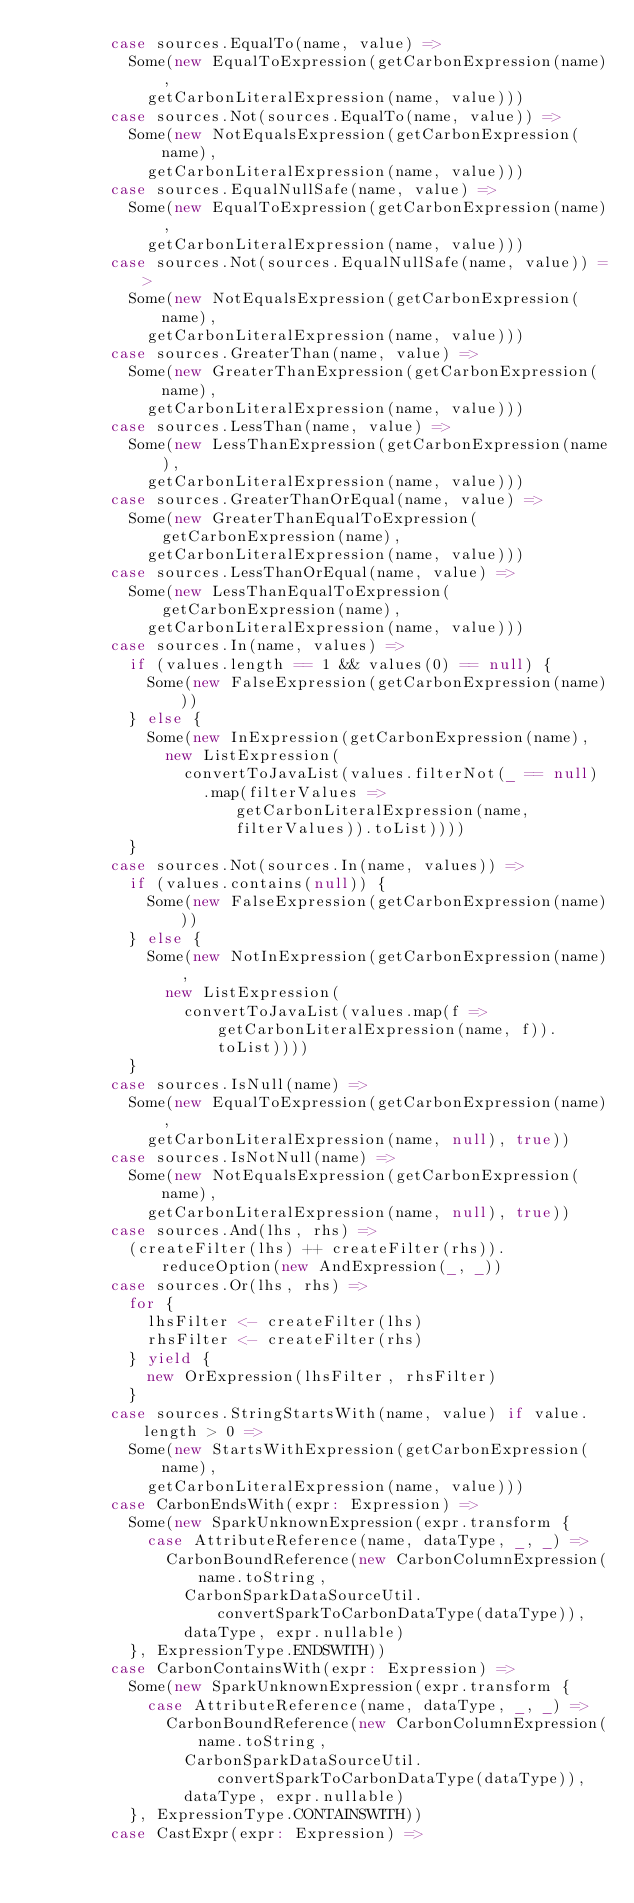<code> <loc_0><loc_0><loc_500><loc_500><_Scala_>        case sources.EqualTo(name, value) =>
          Some(new EqualToExpression(getCarbonExpression(name),
            getCarbonLiteralExpression(name, value)))
        case sources.Not(sources.EqualTo(name, value)) =>
          Some(new NotEqualsExpression(getCarbonExpression(name),
            getCarbonLiteralExpression(name, value)))
        case sources.EqualNullSafe(name, value) =>
          Some(new EqualToExpression(getCarbonExpression(name),
            getCarbonLiteralExpression(name, value)))
        case sources.Not(sources.EqualNullSafe(name, value)) =>
          Some(new NotEqualsExpression(getCarbonExpression(name),
            getCarbonLiteralExpression(name, value)))
        case sources.GreaterThan(name, value) =>
          Some(new GreaterThanExpression(getCarbonExpression(name),
            getCarbonLiteralExpression(name, value)))
        case sources.LessThan(name, value) =>
          Some(new LessThanExpression(getCarbonExpression(name),
            getCarbonLiteralExpression(name, value)))
        case sources.GreaterThanOrEqual(name, value) =>
          Some(new GreaterThanEqualToExpression(getCarbonExpression(name),
            getCarbonLiteralExpression(name, value)))
        case sources.LessThanOrEqual(name, value) =>
          Some(new LessThanEqualToExpression(getCarbonExpression(name),
            getCarbonLiteralExpression(name, value)))
        case sources.In(name, values) =>
          if (values.length == 1 && values(0) == null) {
            Some(new FalseExpression(getCarbonExpression(name)))
          } else {
            Some(new InExpression(getCarbonExpression(name),
              new ListExpression(
                convertToJavaList(values.filterNot(_ == null)
                  .map(filterValues => getCarbonLiteralExpression(name, filterValues)).toList))))
          }
        case sources.Not(sources.In(name, values)) =>
          if (values.contains(null)) {
            Some(new FalseExpression(getCarbonExpression(name)))
          } else {
            Some(new NotInExpression(getCarbonExpression(name),
              new ListExpression(
                convertToJavaList(values.map(f => getCarbonLiteralExpression(name, f)).toList))))
          }
        case sources.IsNull(name) =>
          Some(new EqualToExpression(getCarbonExpression(name),
            getCarbonLiteralExpression(name, null), true))
        case sources.IsNotNull(name) =>
          Some(new NotEqualsExpression(getCarbonExpression(name),
            getCarbonLiteralExpression(name, null), true))
        case sources.And(lhs, rhs) =>
          (createFilter(lhs) ++ createFilter(rhs)).reduceOption(new AndExpression(_, _))
        case sources.Or(lhs, rhs) =>
          for {
            lhsFilter <- createFilter(lhs)
            rhsFilter <- createFilter(rhs)
          } yield {
            new OrExpression(lhsFilter, rhsFilter)
          }
        case sources.StringStartsWith(name, value) if value.length > 0 =>
          Some(new StartsWithExpression(getCarbonExpression(name),
            getCarbonLiteralExpression(name, value)))
        case CarbonEndsWith(expr: Expression) =>
          Some(new SparkUnknownExpression(expr.transform {
            case AttributeReference(name, dataType, _, _) =>
              CarbonBoundReference(new CarbonColumnExpression(name.toString,
                CarbonSparkDataSourceUtil.convertSparkToCarbonDataType(dataType)),
                dataType, expr.nullable)
          }, ExpressionType.ENDSWITH))
        case CarbonContainsWith(expr: Expression) =>
          Some(new SparkUnknownExpression(expr.transform {
            case AttributeReference(name, dataType, _, _) =>
              CarbonBoundReference(new CarbonColumnExpression(name.toString,
                CarbonSparkDataSourceUtil.convertSparkToCarbonDataType(dataType)),
                dataType, expr.nullable)
          }, ExpressionType.CONTAINSWITH))
        case CastExpr(expr: Expression) =></code> 